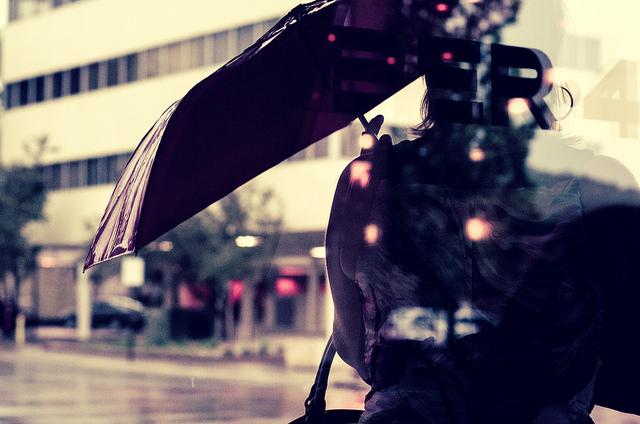Is it raining outside?
Be succinct. Yes. Is that a lady or man holding the umbrella?
Give a very brief answer. Lady. Is there rain on the umbrella?
Answer briefly. Yes. How many raindrops are on the umbrella?
Concise answer only. 0. 